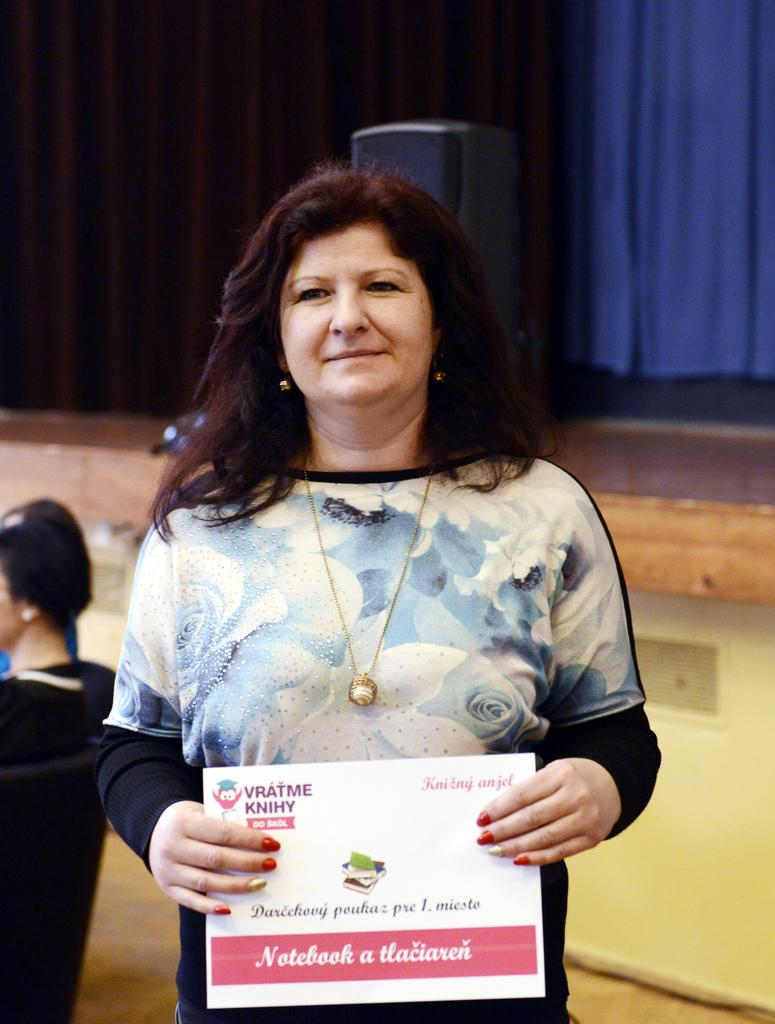Who is the main subject in the image? There is a woman in the image. What is the woman holding in the image? The woman is holding a board. What can be seen on the board that the woman is holding? There is text written on the board. What type of throat lozenge is visible on the board in the image? There is no throat lozenge present on the board in the image; it only has text written on it. 